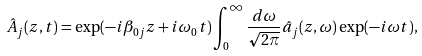<formula> <loc_0><loc_0><loc_500><loc_500>\hat { A } _ { j } ( z , t ) & = \exp ( - i \beta _ { 0 j } z + i \omega _ { 0 } t ) \int _ { 0 } ^ { \infty } \frac { d \omega } { \sqrt { 2 \pi } } \hat { a } _ { j } ( z , \omega ) \exp ( - i \omega t ) ,</formula> 